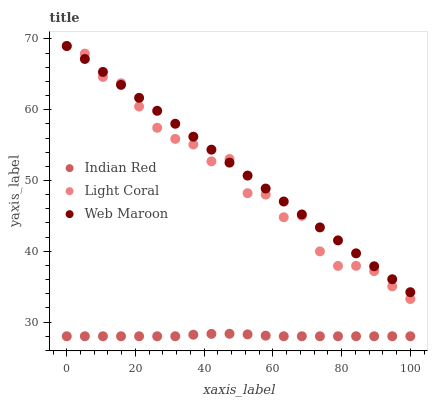Does Indian Red have the minimum area under the curve?
Answer yes or no. Yes. Does Web Maroon have the maximum area under the curve?
Answer yes or no. Yes. Does Web Maroon have the minimum area under the curve?
Answer yes or no. No. Does Indian Red have the maximum area under the curve?
Answer yes or no. No. Is Web Maroon the smoothest?
Answer yes or no. Yes. Is Light Coral the roughest?
Answer yes or no. Yes. Is Indian Red the smoothest?
Answer yes or no. No. Is Indian Red the roughest?
Answer yes or no. No. Does Indian Red have the lowest value?
Answer yes or no. Yes. Does Web Maroon have the lowest value?
Answer yes or no. No. Does Web Maroon have the highest value?
Answer yes or no. Yes. Does Indian Red have the highest value?
Answer yes or no. No. Is Indian Red less than Web Maroon?
Answer yes or no. Yes. Is Web Maroon greater than Indian Red?
Answer yes or no. Yes. Does Light Coral intersect Web Maroon?
Answer yes or no. Yes. Is Light Coral less than Web Maroon?
Answer yes or no. No. Is Light Coral greater than Web Maroon?
Answer yes or no. No. Does Indian Red intersect Web Maroon?
Answer yes or no. No. 